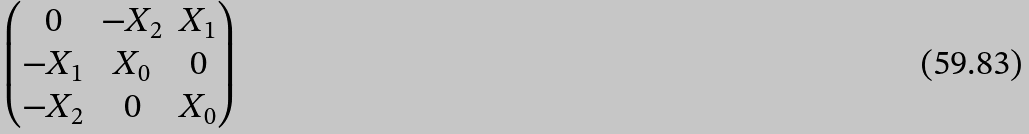<formula> <loc_0><loc_0><loc_500><loc_500>\begin{pmatrix} 0 & - X _ { 2 } & X _ { 1 } \\ - X _ { 1 } & X _ { 0 } & 0 \\ - X _ { 2 } & 0 & X _ { 0 } \end{pmatrix}</formula> 